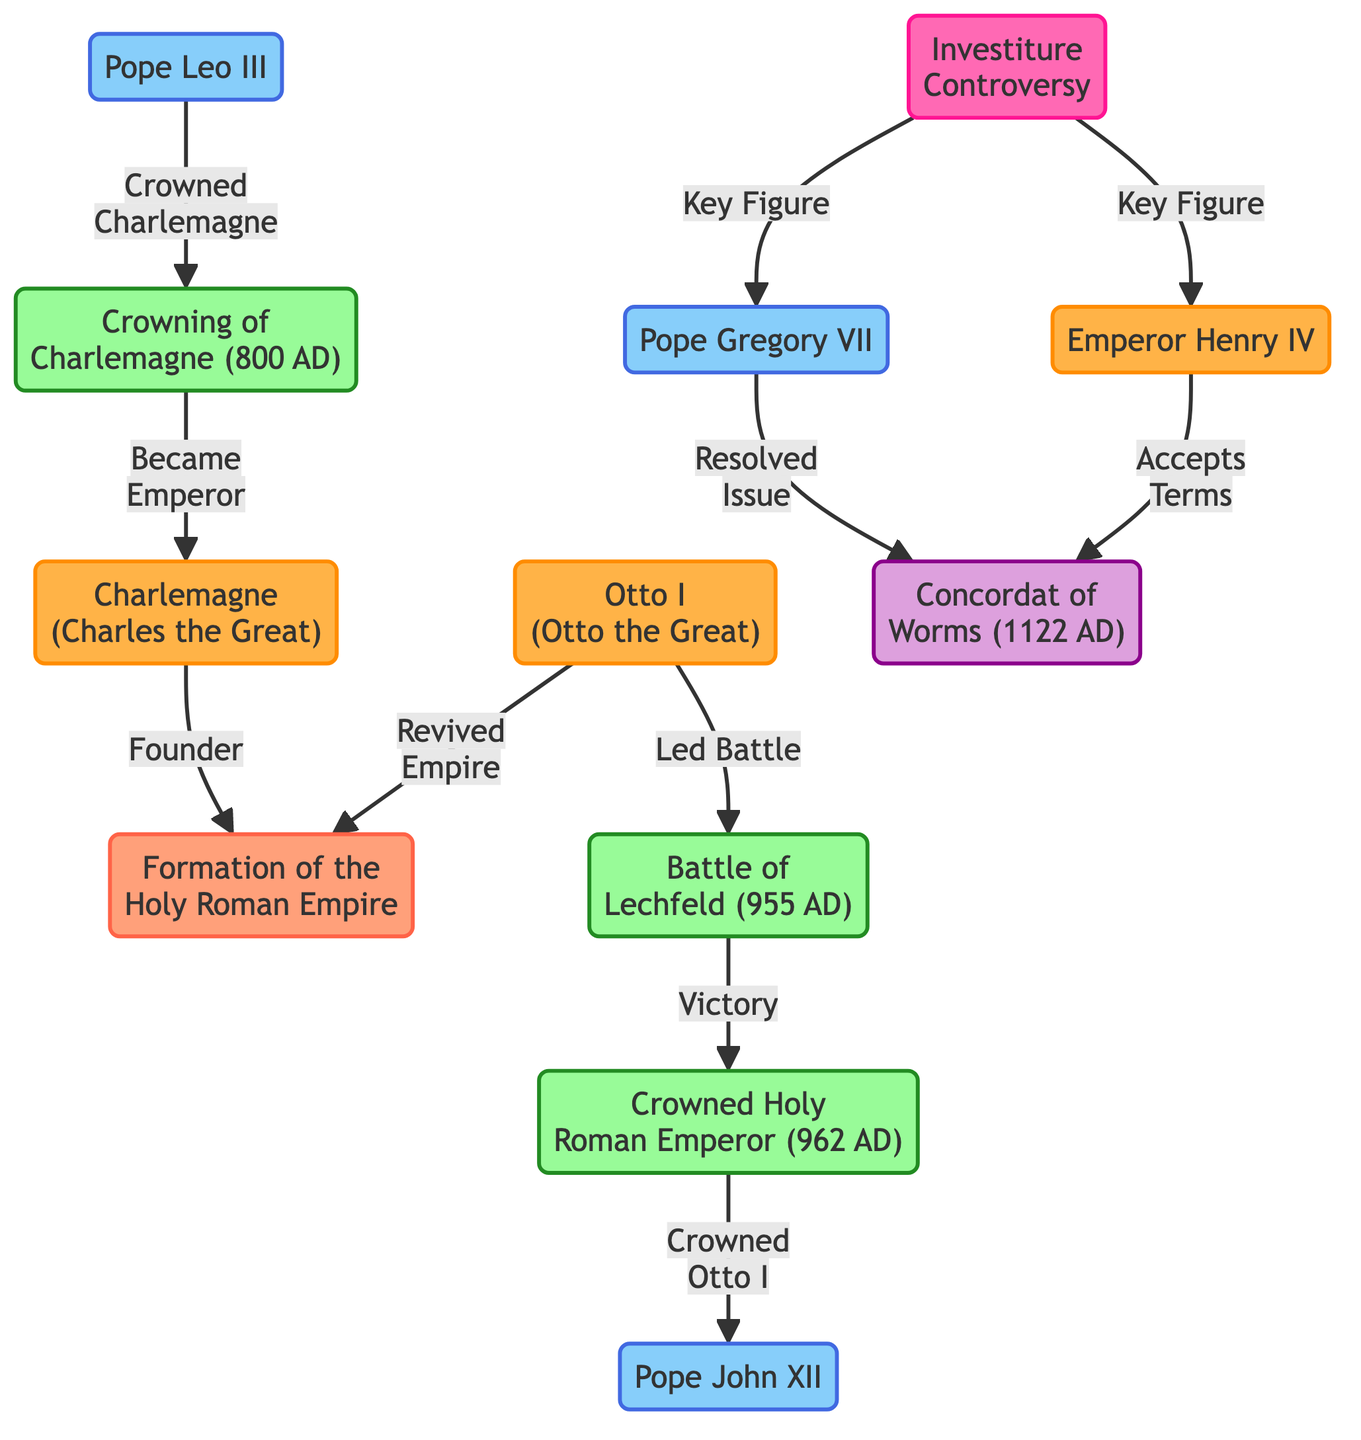What is the title of the diagram? The title of the diagram is usually indicative of its content, which can be inferred from the data. Since the information revolves around the formation of a significant historical political entity intertwined with religious influences, the title is likely "The Formation of the Holy Roman Empire: A Hierarchical Diagram Showcasing the Relationship Between Church and State."
Answer: The Formation of the Holy Roman Empire: A Hierarchical Diagram Showcasing the Relationship Between Church and State Who crowned Charlemagne? By examining the directed edge from the "Pope Leo III" node to the "Crowning of Charlemagne" event, we can determine who performed the coronation. The diagram clearly indicates that it was Pope Leo III who crowned him.
Answer: Pope Leo III What year did Charlemagne become emperor? The diagram details the event of Charlemagne's crowning, which is specifically noted as occurring in 800 AD. Thus, the answer stems from this labeled event.
Answer: 800 AD Who led the Battle of Lechfeld? Investigating the nodes connected to the "Battle of Lechfeld" event reveals that "Otto I (Otto the Great)" is directly linked as the leader of this battle. Therefore, the answer is derived from the relationship described in the diagram.
Answer: Otto I What significant agreement resulted from the Investiture Controversy? The diagram describes a conflict labeled "Investiture Controversy," which leads to another node called "Concordat of Worms." Hence, the resolution of this controversy is represented in the diagram as the Concordat of Worms.
Answer: Concordat of Worms How many religious leaders are represented in the diagram? The diagram includes nodes specifically marked for individuals holding religious leadership roles. By counting the nodes labeled as religious leaders—Pope Leo III, Pope John XII, Pope Gregory VII—the total number can be determined. In this case, there are three such leaders.
Answer: 3 How is Otto I connected to the Holy Roman Empire? Looking at the nodes connected to "Otto I," we find an edge leading to both the "Battle of Lechfeld" and the "Formation of the Holy Roman Empire." He is directly connected as a ruler who revived the empire after his crowning as Holy Roman Emperor, thus establishing his role in its formation.
Answer: Revived Empire What event occurred after the Battle of Lechfeld? The diagram establishes a sequential relationship where "Battle of Lechfeld" leads to "Crowned Holy Roman Emperor." Following this logic, we can ascertain that the crowning ceremony is the event that follows the battle.
Answer: Crowned Holy Roman Emperor Who was a key figure in the Investiture Controversy? The diagram explicitly identifies both "Pope Gregory VII" and "Emperor Henry IV" as key figures involved in the Investiture Controversy, indicating that both individuals share this significant role in the conflict outlined within the diagram.
Answer: Pope Gregory VII and Emperor Henry IV 